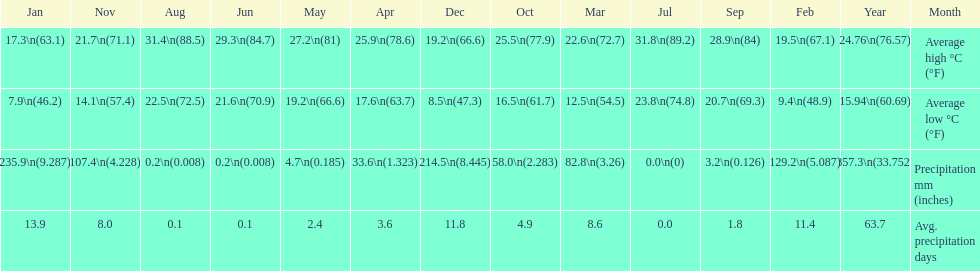Which country is haifa in? Israel. 